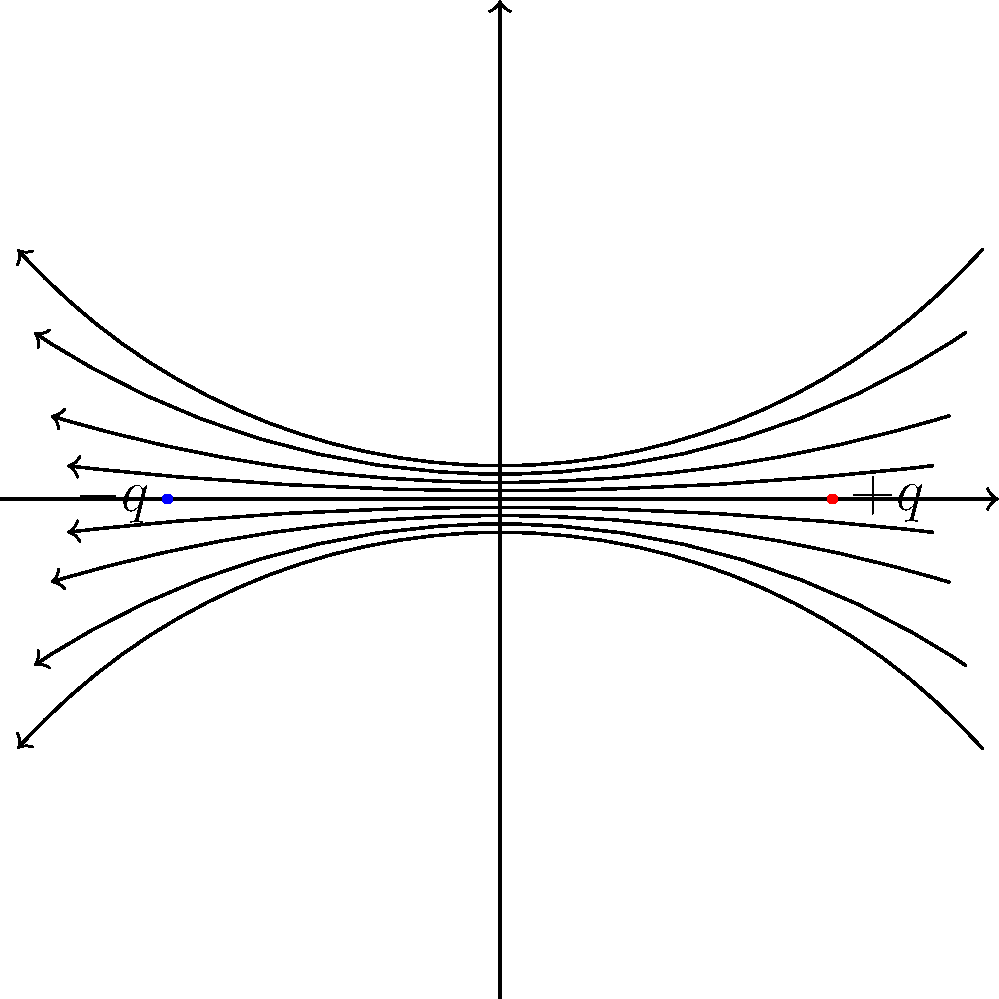As a digital media specialist verifying online information about physics, you come across an image depicting electric field lines between two charged particles. Based on the diagram, what can you conclude about the relative charges of the two particles and the direction of the electric field? To analyze this diagram and verify the information it conveys, let's break it down step-by-step:

1. Particle charges:
   - The particle on the right is labeled with "$+q$", indicating a positive charge.
   - The particle on the left is labeled with "$-q$", indicating a negative charge.
   - The charges appear to be equal in magnitude but opposite in sign.

2. Electric field lines:
   - The lines start from the positive charge and end at the negative charge.
   - This is consistent with the convention that electric field lines originate from positive charges and terminate on negative charges.

3. Direction of the electric field:
   - The arrows on the field lines point from the positive charge to the negative charge.
   - This indicates that the electric field is directed from positive to negative, which is the correct convention.

4. Shape of the field lines:
   - The lines are curved, bulging outward between the charges.
   - This is characteristic of the field between two point charges of opposite sign.

5. Symmetry:
   - The field lines are symmetrically distributed around the axis connecting the two charges.
   - This symmetry is expected for two point charges of equal magnitude and opposite sign.

6. Density of field lines:
   - The field lines are more concentrated near the charges and less dense in the middle.
   - This correctly represents the stronger field near the charges and weaker field in between.

Based on this analysis, we can conclude that the diagram accurately represents the electric field between two point charges of equal magnitude and opposite sign, with the field directed from the positive charge to the negative charge.
Answer: The diagram shows two particles with equal but opposite charges ($+q$ and $-q$), and the electric field is directed from the positive charge to the negative charge. 